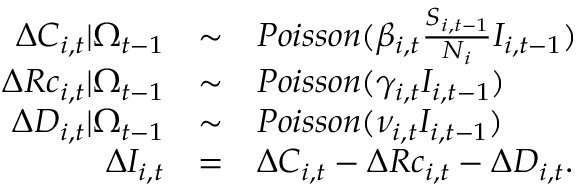<formula> <loc_0><loc_0><loc_500><loc_500>\begin{array} { r c l } { \Delta C _ { i , t } | \Omega _ { t - 1 } } & { \sim } & { P o i s s o n ( \beta _ { i , t } \frac { S _ { i , t - 1 } } { N _ { i } } I _ { i , t - 1 } ) } \\ { \Delta R c _ { i , t } | \Omega _ { t - 1 } } & { \sim } & { P o i s s o n ( \gamma _ { i , t } I _ { i , t - 1 } ) } \\ { \Delta D _ { i , t } | \Omega _ { t - 1 } } & { \sim } & { P o i s s o n ( \nu _ { i , t } I _ { i , t - 1 } ) } \\ { \Delta I _ { i , t } } & { = } & { \Delta C _ { i , t } - \Delta R c _ { i , t } - \Delta D _ { i , t } . } \end{array}</formula> 